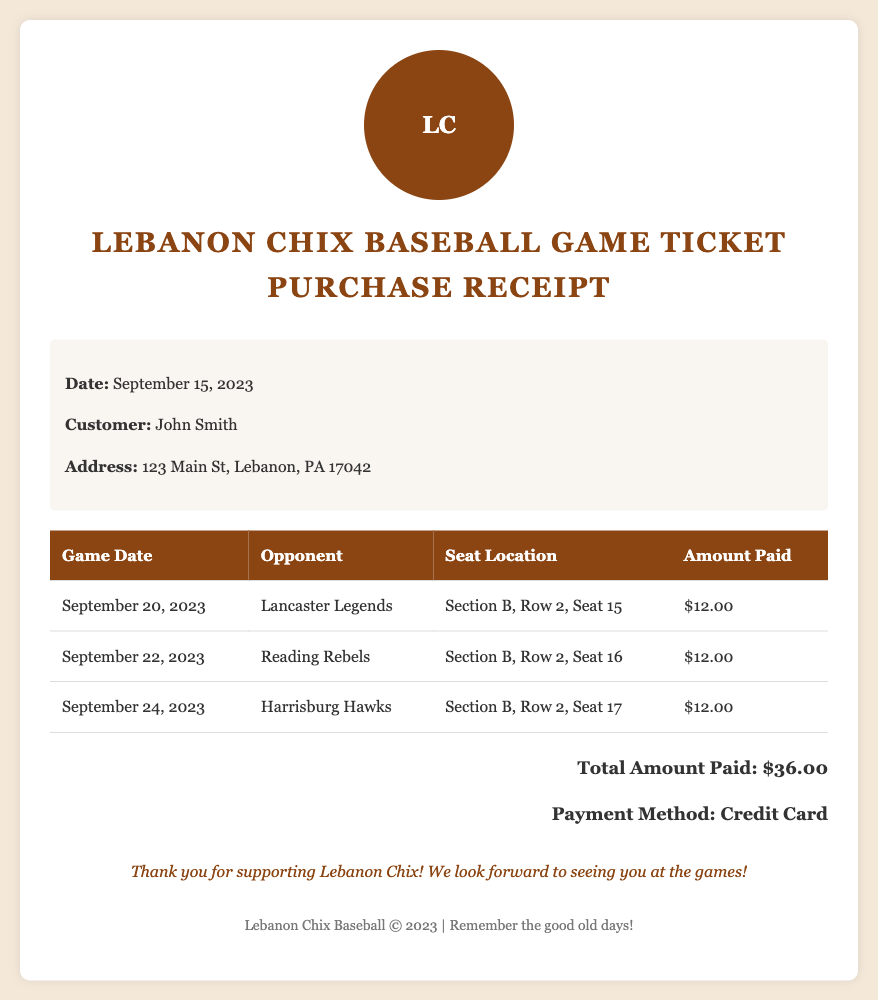What is the date of the receipt? The date of the receipt is explicitly mentioned in the document under customer information.
Answer: September 15, 2023 Who is the customer? The customer's name is stated under the customer information section of the document.
Answer: John Smith How much was paid for the game against Lancaster Legends? The amount paid for each game is detailed in the table, specifically for that opponent.
Answer: $12.00 What is the total amount paid for all tickets? The total amount paid is provided at the end of the receipt and is the sum of the ticket prices.
Answer: $36.00 What is the seat location for the game on September 24, 2023? The seat location is provided in the table for that specific game date.
Answer: Section B, Row 2, Seat 17 What was the opponent for the game on September 22, 2023? The opponent details are clearly listed in the table for that game date.
Answer: Reading Rebels What payment method was used? The payment method is mentioned in the total amount section of the document.
Answer: Credit Card How many games are listed on the receipt? The number of games is indicated by the number of rows in the table.
Answer: 3 What is the color of the receipt's background? The background color is specified in the document's style section and contributes to the overall appearance of the receipt.
Answer: #f4e8d9 